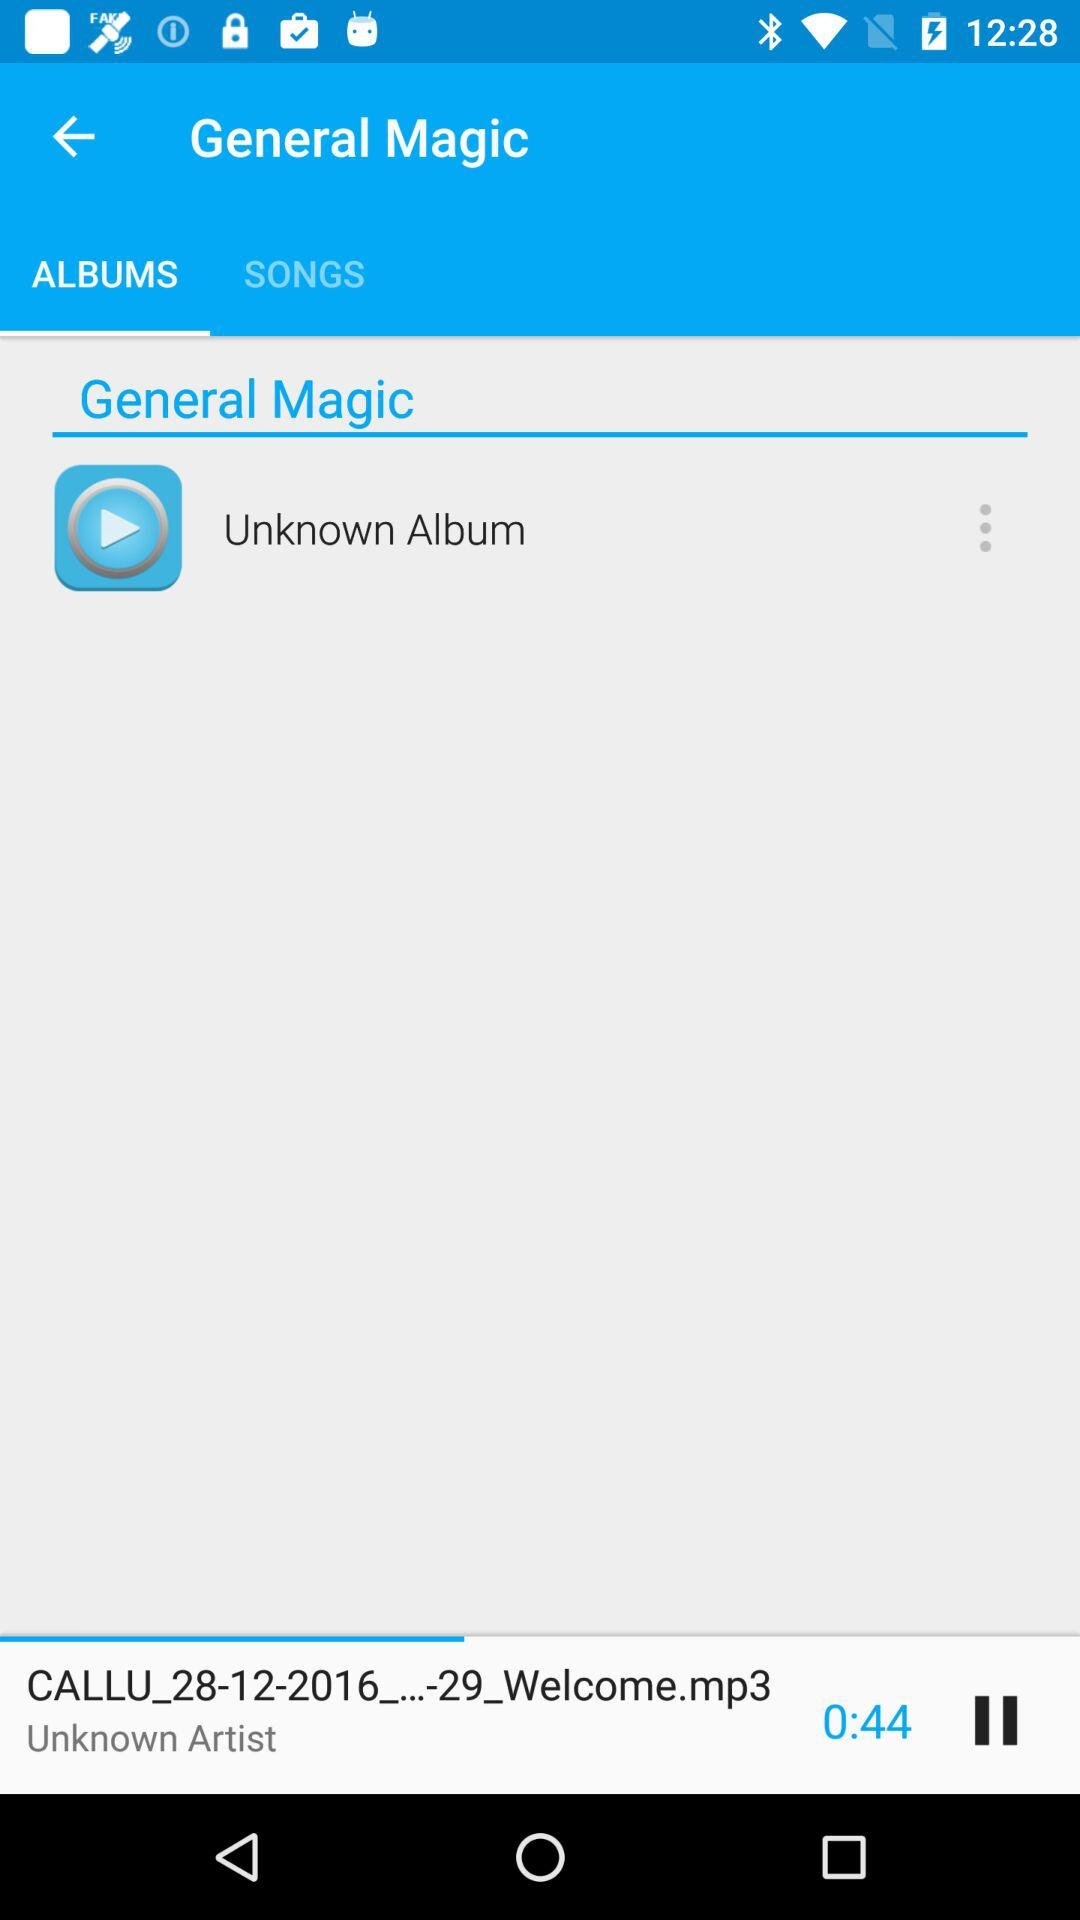What is the duration of the currently playing song? The duration of the currently playing song is 44 seconds. 